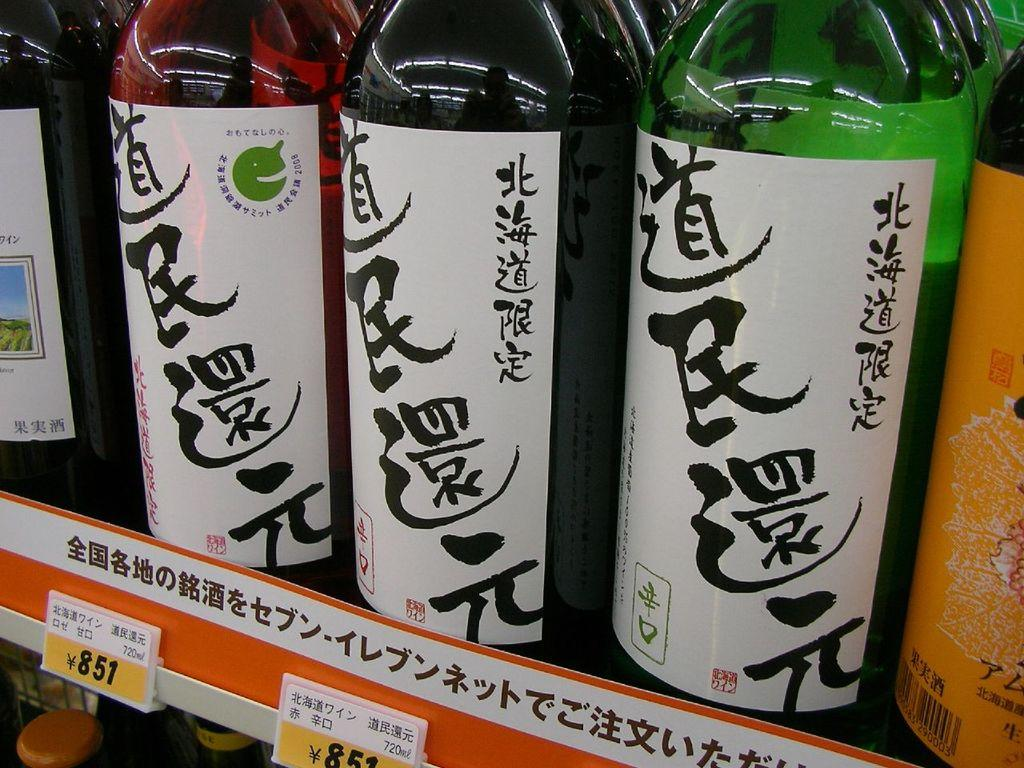<image>
Render a clear and concise summary of the photo. The number 851 appears below a bottle on a shelf. 